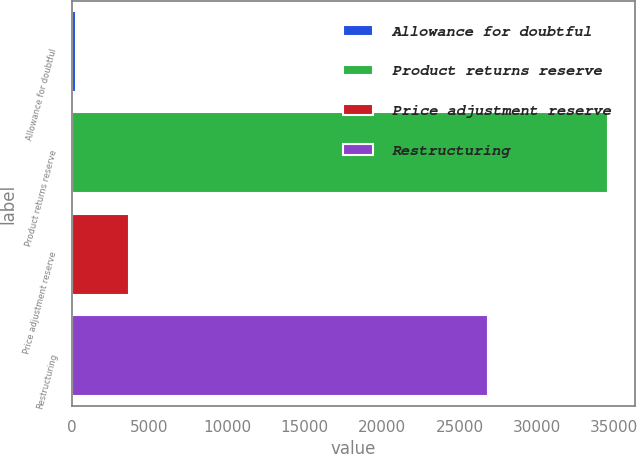<chart> <loc_0><loc_0><loc_500><loc_500><bar_chart><fcel>Allowance for doubtful<fcel>Product returns reserve<fcel>Price adjustment reserve<fcel>Restructuring<nl><fcel>236<fcel>34598<fcel>3672.2<fcel>26837<nl></chart> 